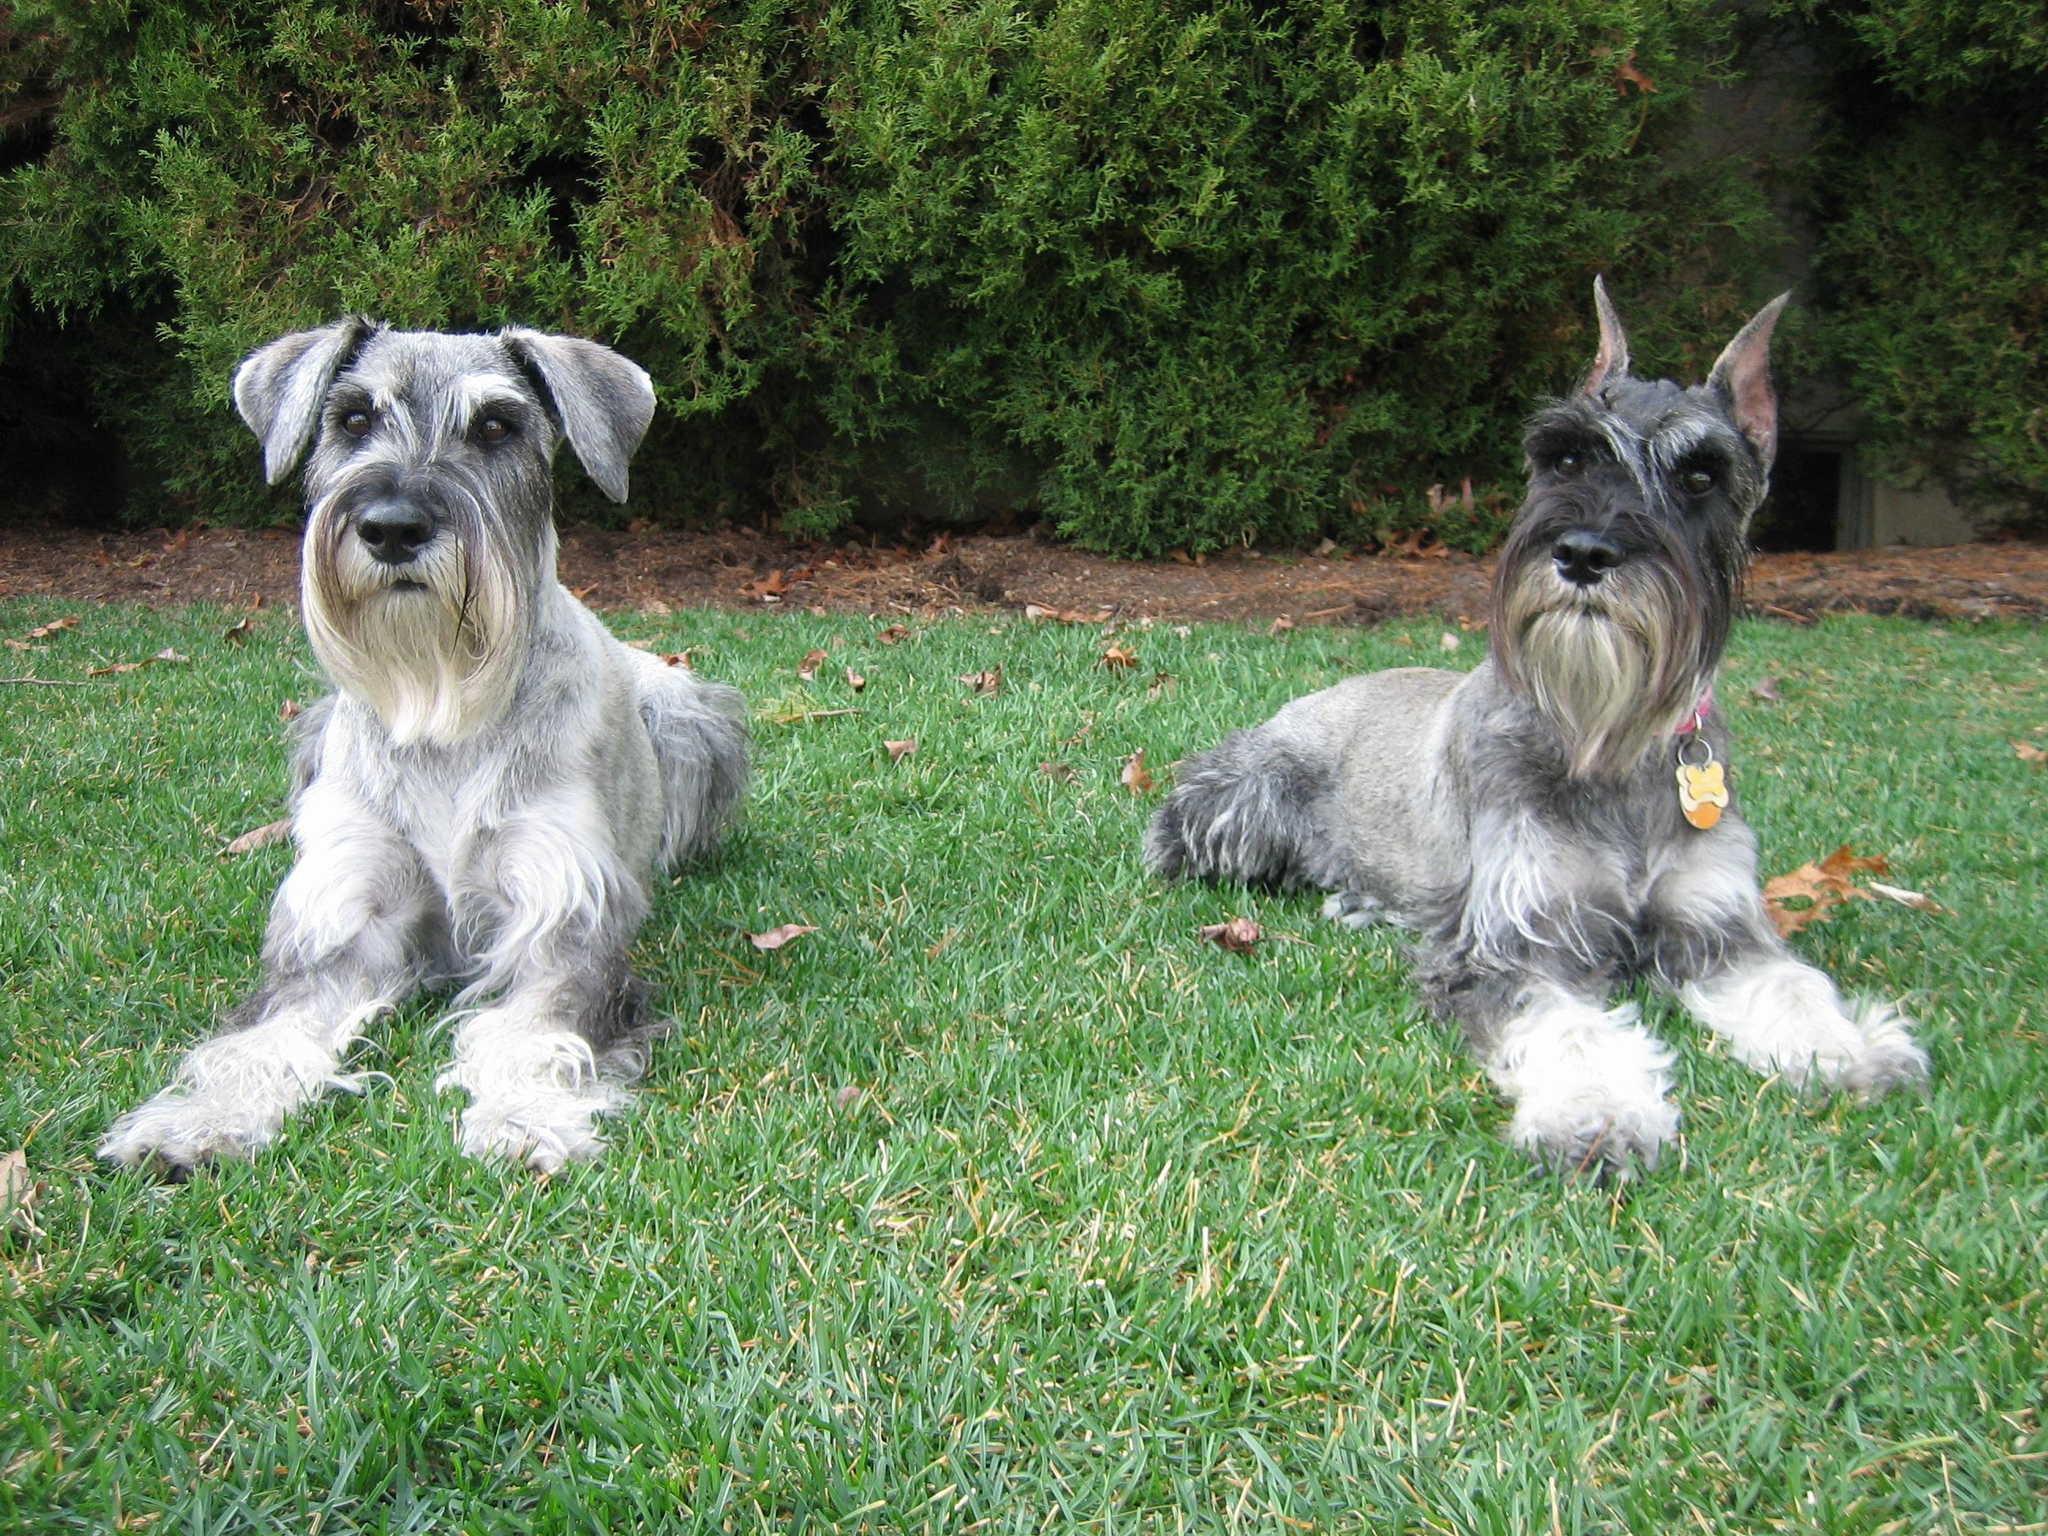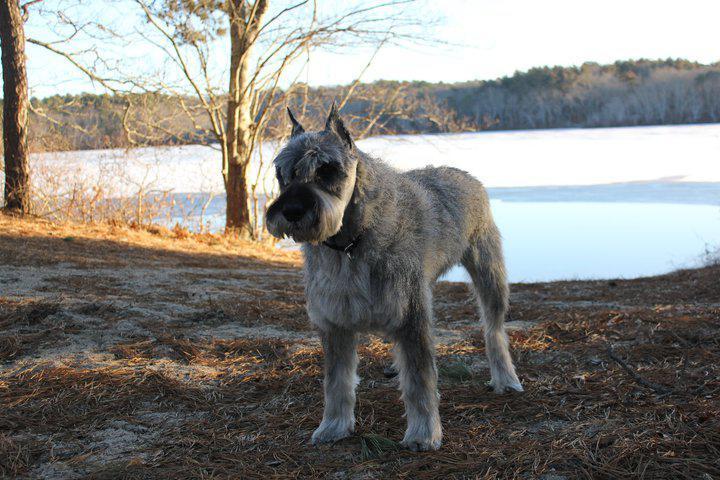The first image is the image on the left, the second image is the image on the right. Considering the images on both sides, is "At least one of the dogs is sitting on the cement." valid? Answer yes or no. No. 